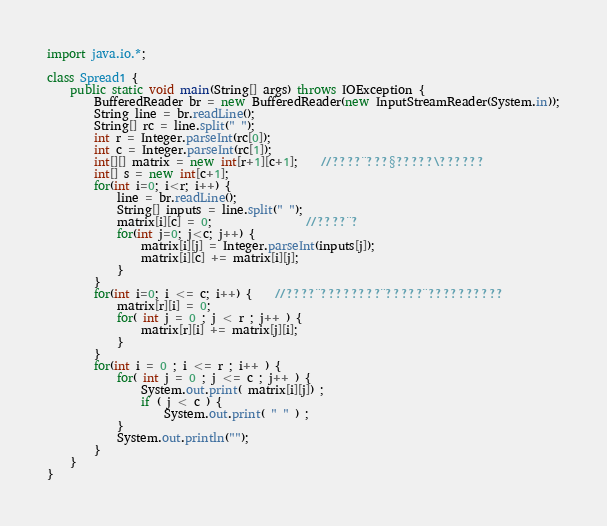<code> <loc_0><loc_0><loc_500><loc_500><_Java_>import java.io.*;
 
class Spread1 {
    public static void main(String[] args) throws IOException {
        BufferedReader br = new BufferedReader(new InputStreamReader(System.in));
        String line = br.readLine();
        String[] rc = line.split(" ");
        int r = Integer.parseInt(rc[0]);
        int c = Integer.parseInt(rc[1]);
        int[][] matrix = new int[r+1][c+1];	//????¨???§?????\??????
        int[] s = new int[c+1];
        for(int i=0; i<r; i++) {
            line = br.readLine();
            String[] inputs = line.split(" ");
            matrix[i][c] = 0;				//????¨?
            for(int j=0; j<c; j++) {
                matrix[i][j] = Integer.parseInt(inputs[j]);
                matrix[i][c] += matrix[i][j];
            }
        }
        for(int i=0; i <= c; i++) {	//????¨????????¨?????¨??????????
			matrix[r][i] = 0;
			for( int j = 0 ; j < r ; j++ ) {
				matrix[r][i] += matrix[j][i];
			}
        }
        for(int i = 0 ; i <= r ; i++ ) {
			for( int j = 0 ; j <= c ; j++ ) {
				System.out.print( matrix[i][j]) ;
				if ( j < c ) {
					System.out.print( " " ) ;
			}
			System.out.println("");
		}
    }
}</code> 